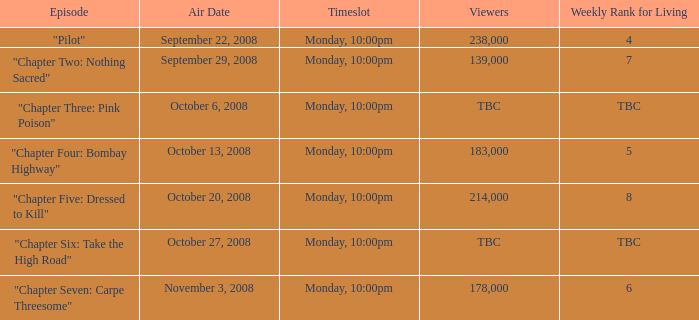What is the episode with the 183,000 viewers? "Chapter Four: Bombay Highway". 